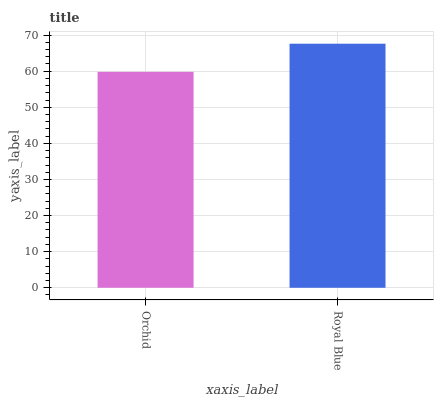Is Orchid the minimum?
Answer yes or no. Yes. Is Royal Blue the maximum?
Answer yes or no. Yes. Is Royal Blue the minimum?
Answer yes or no. No. Is Royal Blue greater than Orchid?
Answer yes or no. Yes. Is Orchid less than Royal Blue?
Answer yes or no. Yes. Is Orchid greater than Royal Blue?
Answer yes or no. No. Is Royal Blue less than Orchid?
Answer yes or no. No. Is Royal Blue the high median?
Answer yes or no. Yes. Is Orchid the low median?
Answer yes or no. Yes. Is Orchid the high median?
Answer yes or no. No. Is Royal Blue the low median?
Answer yes or no. No. 